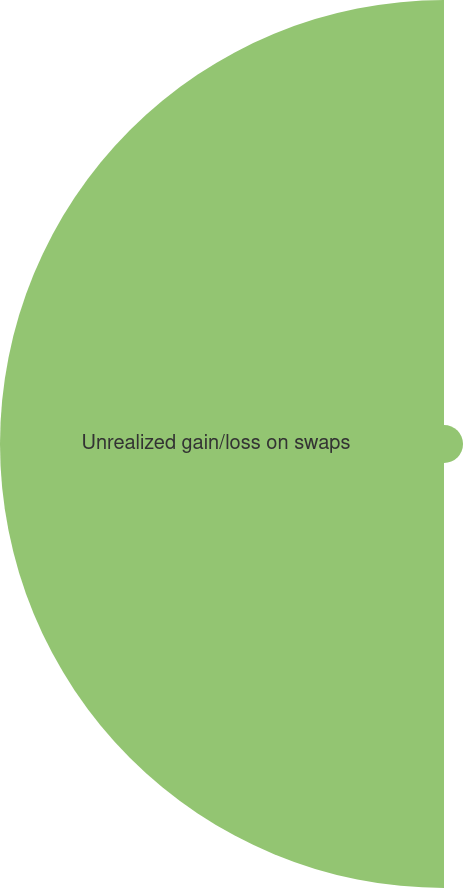Convert chart. <chart><loc_0><loc_0><loc_500><loc_500><pie_chart><fcel>Securities available for sale<fcel>Unrealized gain/loss on swaps<nl><fcel>4.11%<fcel>95.89%<nl></chart> 